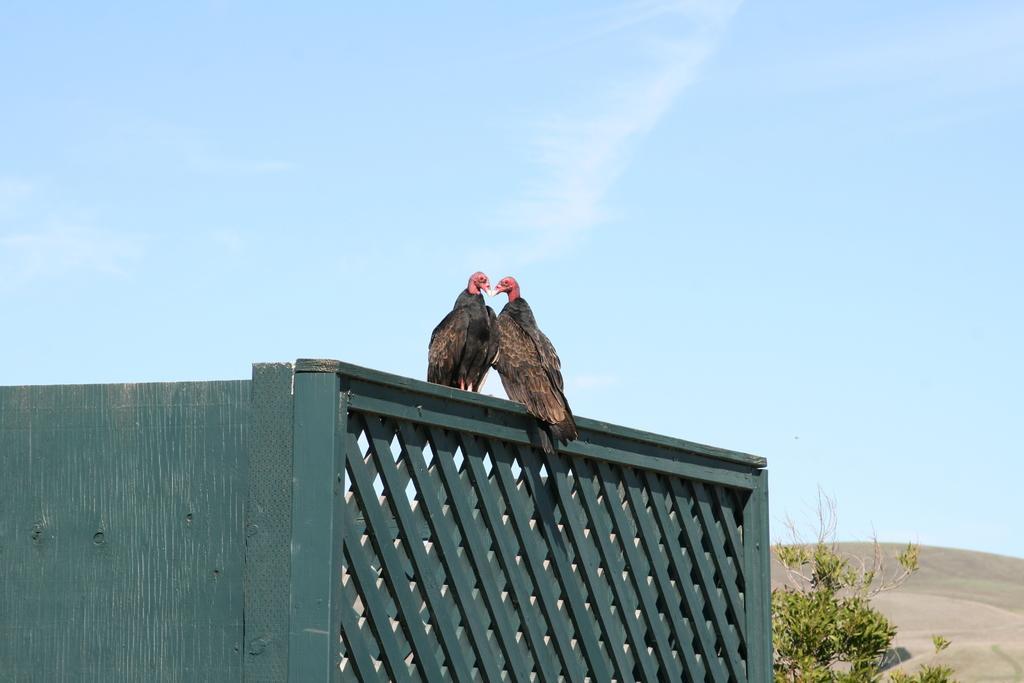Could you give a brief overview of what you see in this image? This is a wooden wall. On that there are two vultures. Near to that there is a tree. In the back there is sky. 